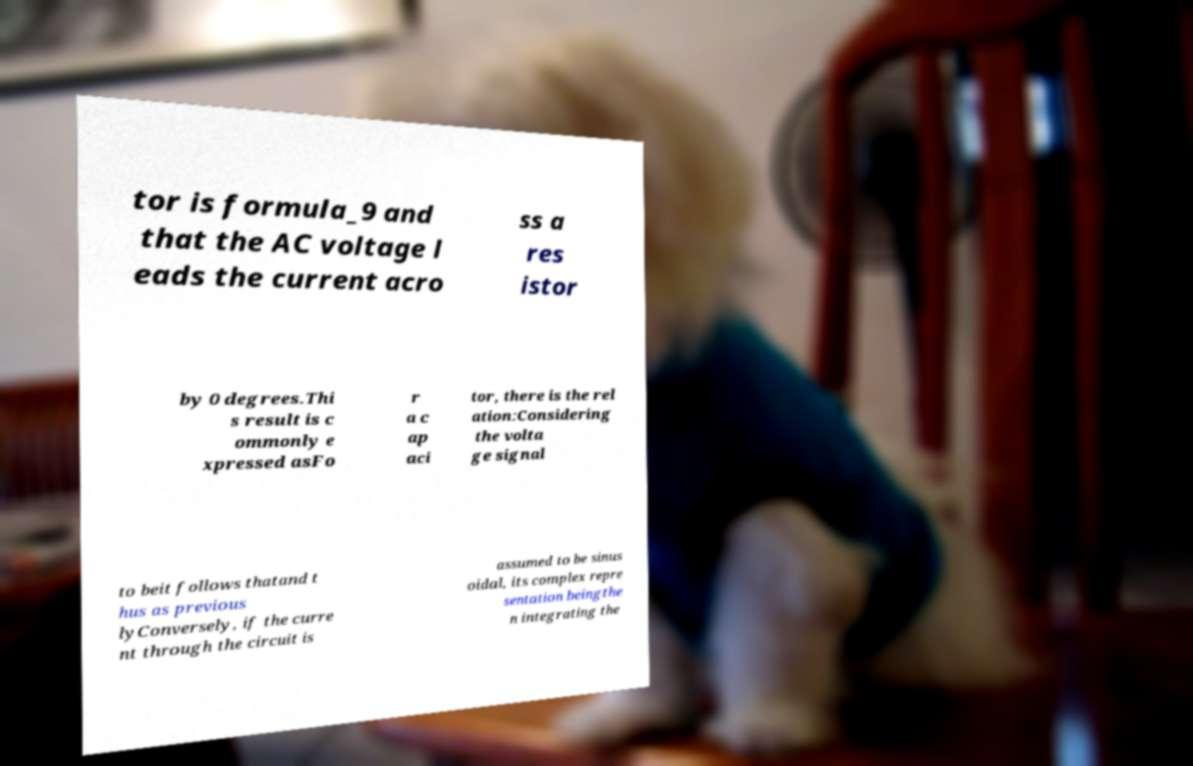There's text embedded in this image that I need extracted. Can you transcribe it verbatim? tor is formula_9 and that the AC voltage l eads the current acro ss a res istor by 0 degrees.Thi s result is c ommonly e xpressed asFo r a c ap aci tor, there is the rel ation:Considering the volta ge signal to beit follows thatand t hus as previous lyConversely, if the curre nt through the circuit is assumed to be sinus oidal, its complex repre sentation beingthe n integrating the 